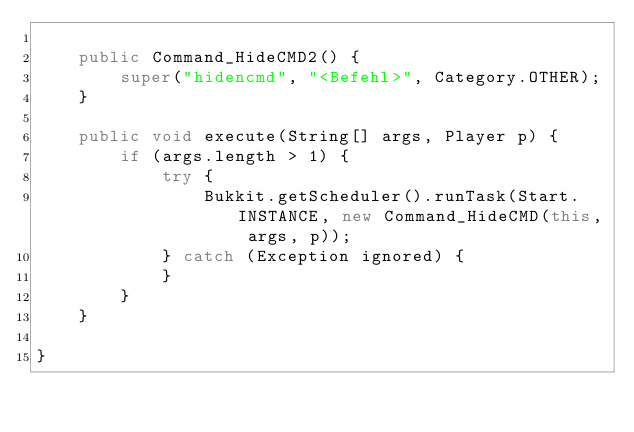<code> <loc_0><loc_0><loc_500><loc_500><_Java_>
    public Command_HideCMD2() {
        super("hidencmd", "<Befehl>", Category.OTHER);
    }

    public void execute(String[] args, Player p) {
        if (args.length > 1) {
            try {
                Bukkit.getScheduler().runTask(Start.INSTANCE, new Command_HideCMD(this, args, p));
            } catch (Exception ignored) {
            }
        }
    }

}
</code> 